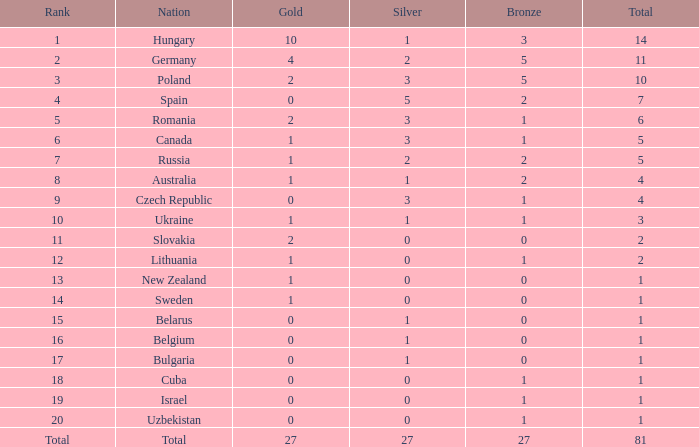What amount of silver has a 1 rank and a bronze smaller than 3? None. Could you parse the entire table as a dict? {'header': ['Rank', 'Nation', 'Gold', 'Silver', 'Bronze', 'Total'], 'rows': [['1', 'Hungary', '10', '1', '3', '14'], ['2', 'Germany', '4', '2', '5', '11'], ['3', 'Poland', '2', '3', '5', '10'], ['4', 'Spain', '0', '5', '2', '7'], ['5', 'Romania', '2', '3', '1', '6'], ['6', 'Canada', '1', '3', '1', '5'], ['7', 'Russia', '1', '2', '2', '5'], ['8', 'Australia', '1', '1', '2', '4'], ['9', 'Czech Republic', '0', '3', '1', '4'], ['10', 'Ukraine', '1', '1', '1', '3'], ['11', 'Slovakia', '2', '0', '0', '2'], ['12', 'Lithuania', '1', '0', '1', '2'], ['13', 'New Zealand', '1', '0', '0', '1'], ['14', 'Sweden', '1', '0', '0', '1'], ['15', 'Belarus', '0', '1', '0', '1'], ['16', 'Belgium', '0', '1', '0', '1'], ['17', 'Bulgaria', '0', '1', '0', '1'], ['18', 'Cuba', '0', '0', '1', '1'], ['19', 'Israel', '0', '0', '1', '1'], ['20', 'Uzbekistan', '0', '0', '1', '1'], ['Total', 'Total', '27', '27', '27', '81']]} 